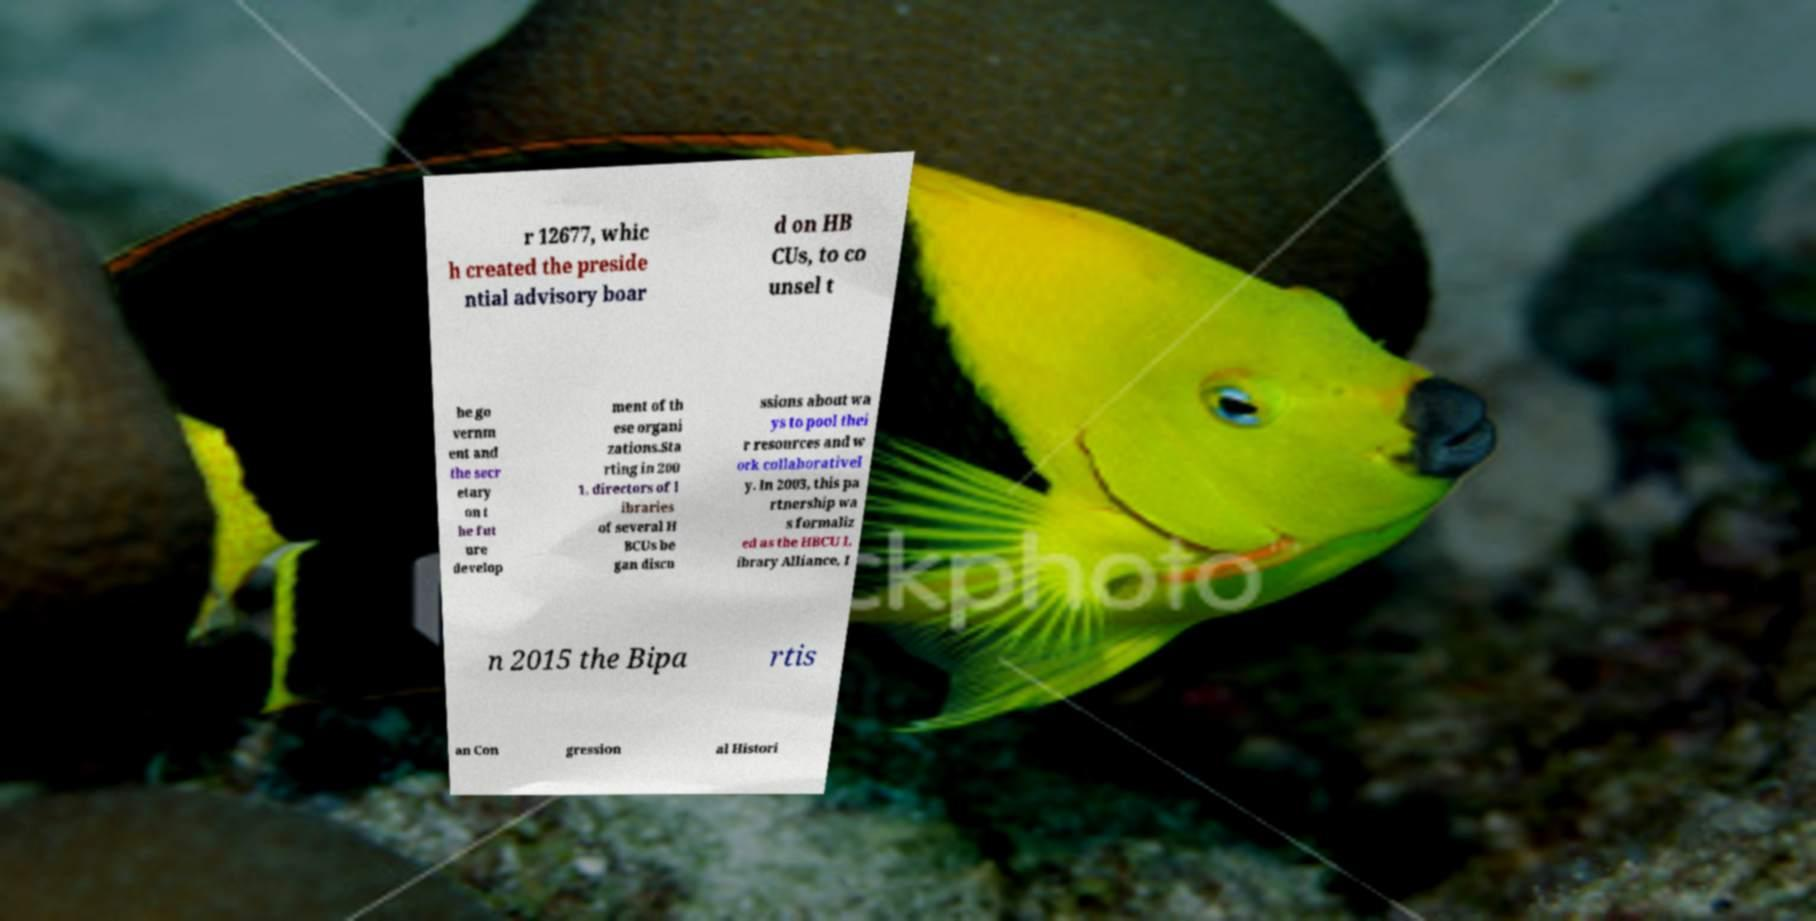Please identify and transcribe the text found in this image. r 12677, whic h created the preside ntial advisory boar d on HB CUs, to co unsel t he go vernm ent and the secr etary on t he fut ure develop ment of th ese organi zations.Sta rting in 200 1, directors of l ibraries of several H BCUs be gan discu ssions about wa ys to pool thei r resources and w ork collaborativel y. In 2003, this pa rtnership wa s formaliz ed as the HBCU L ibrary Alliance, I n 2015 the Bipa rtis an Con gression al Histori 